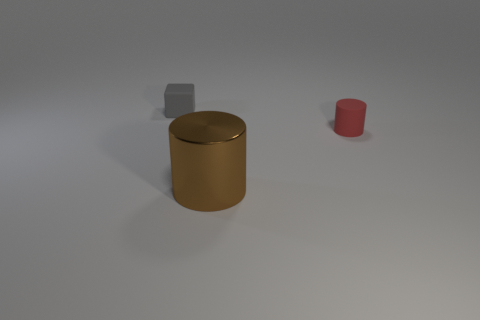Is there any other thing that is the same size as the brown shiny thing?
Ensure brevity in your answer.  No. Are there any other things that have the same shape as the small gray matte object?
Your answer should be very brief. No. Is there anything else that is the same material as the big thing?
Give a very brief answer. No. There is a tiny object that is to the left of the small matte object in front of the tiny thing left of the brown cylinder; what is its material?
Give a very brief answer. Rubber. Is the shape of the brown thing the same as the tiny red matte object?
Your answer should be very brief. Yes. What is the material of the other object that is the same shape as the big object?
Your response must be concise. Rubber. What number of large metallic objects have the same color as the rubber cylinder?
Make the answer very short. 0. What number of gray things are tiny shiny cubes or cylinders?
Provide a short and direct response. 0. How many things are behind the tiny thing that is in front of the small gray block?
Offer a terse response. 1. Is the number of small red rubber cylinders that are to the right of the big metallic cylinder greater than the number of red matte objects that are left of the tiny gray matte thing?
Your answer should be compact. Yes. 